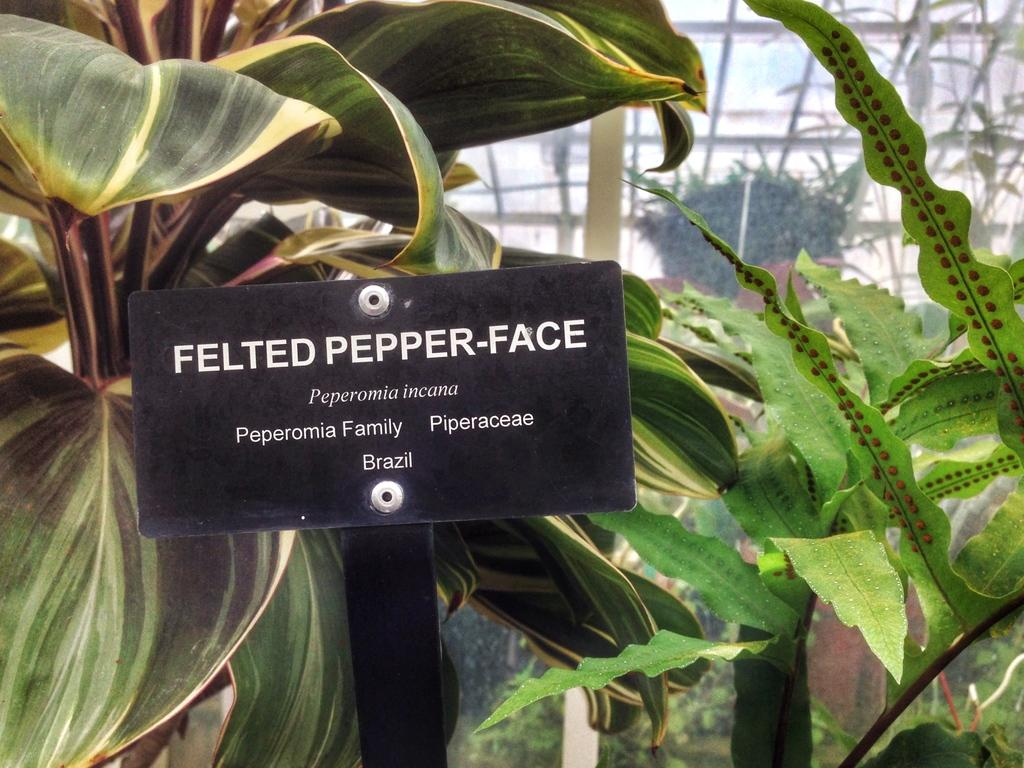What is the main object in the image? There is a black color board in the image. What is written on the color board? The name "Felted Pepperface" is written on the board. What type of vegetation can be seen in the image? There are plants visible in the image. What can be seen in the background of the image? There is a glass roof in the background of the image. How much payment is required to enter the wooden treehouse in the image? There is no wooden treehouse present in the image, so it is not possible to determine any payment requirements. 